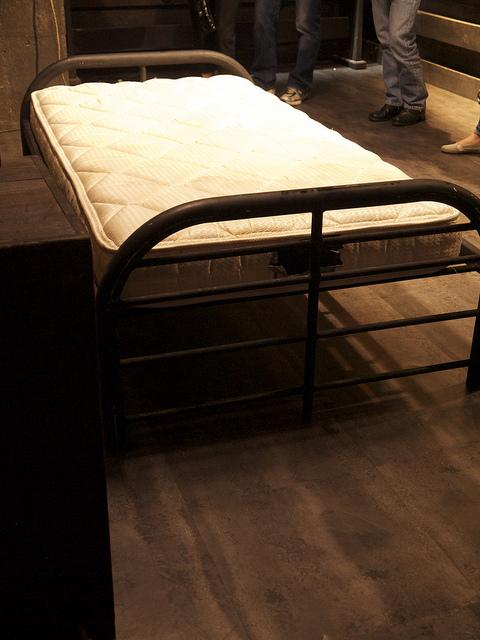What usually happens on the item in the middle of the room? Please explain your reasoning. sleeping. Sleeping happens. 